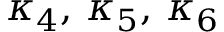<formula> <loc_0><loc_0><loc_500><loc_500>\kappa _ { 4 } , \, \kappa _ { 5 } , \, \kappa _ { 6 }</formula> 